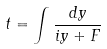Convert formula to latex. <formula><loc_0><loc_0><loc_500><loc_500>t = \int \frac { d y } { i y + F }</formula> 